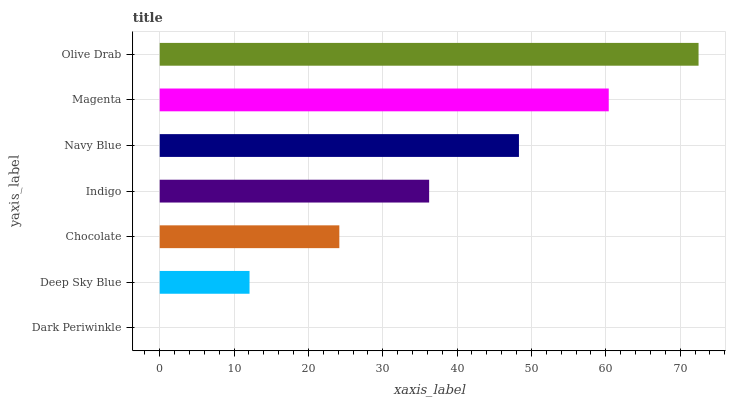Is Dark Periwinkle the minimum?
Answer yes or no. Yes. Is Olive Drab the maximum?
Answer yes or no. Yes. Is Deep Sky Blue the minimum?
Answer yes or no. No. Is Deep Sky Blue the maximum?
Answer yes or no. No. Is Deep Sky Blue greater than Dark Periwinkle?
Answer yes or no. Yes. Is Dark Periwinkle less than Deep Sky Blue?
Answer yes or no. Yes. Is Dark Periwinkle greater than Deep Sky Blue?
Answer yes or no. No. Is Deep Sky Blue less than Dark Periwinkle?
Answer yes or no. No. Is Indigo the high median?
Answer yes or no. Yes. Is Indigo the low median?
Answer yes or no. Yes. Is Olive Drab the high median?
Answer yes or no. No. Is Magenta the low median?
Answer yes or no. No. 